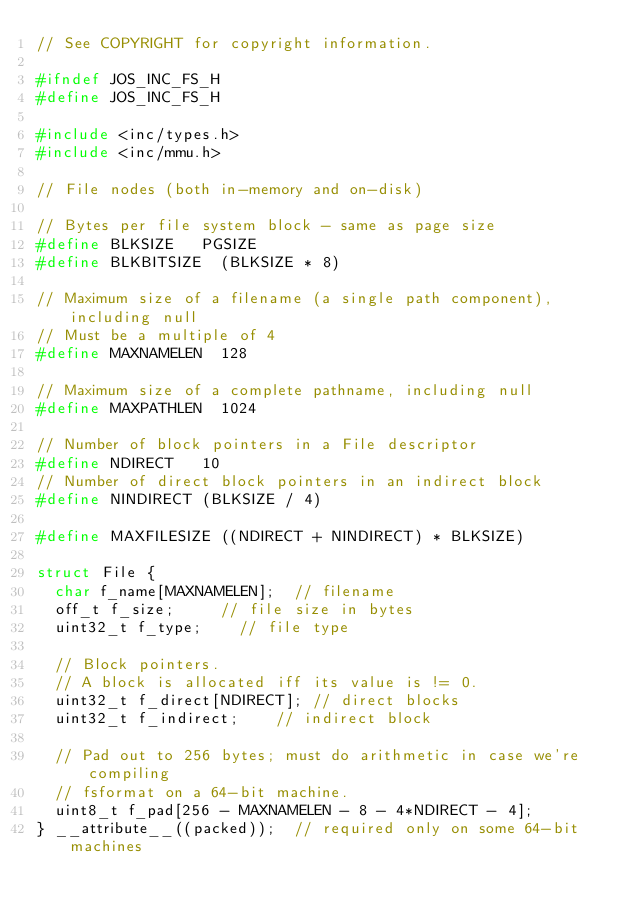<code> <loc_0><loc_0><loc_500><loc_500><_C_>// See COPYRIGHT for copyright information.

#ifndef JOS_INC_FS_H
#define JOS_INC_FS_H

#include <inc/types.h>
#include <inc/mmu.h>

// File nodes (both in-memory and on-disk)

// Bytes per file system block - same as page size
#define BLKSIZE		PGSIZE
#define BLKBITSIZE	(BLKSIZE * 8)

// Maximum size of a filename (a single path component), including null
// Must be a multiple of 4
#define MAXNAMELEN	128

// Maximum size of a complete pathname, including null
#define MAXPATHLEN	1024

// Number of block pointers in a File descriptor
#define NDIRECT		10
// Number of direct block pointers in an indirect block
#define NINDIRECT	(BLKSIZE / 4)

#define MAXFILESIZE	((NDIRECT + NINDIRECT) * BLKSIZE)

struct File {
	char f_name[MAXNAMELEN];	// filename
	off_t f_size;			// file size in bytes
	uint32_t f_type;		// file type

	// Block pointers.
	// A block is allocated iff its value is != 0.
	uint32_t f_direct[NDIRECT];	// direct blocks
	uint32_t f_indirect;		// indirect block

	// Pad out to 256 bytes; must do arithmetic in case we're compiling
	// fsformat on a 64-bit machine.
	uint8_t f_pad[256 - MAXNAMELEN - 8 - 4*NDIRECT - 4];
} __attribute__((packed));	// required only on some 64-bit machines
</code> 